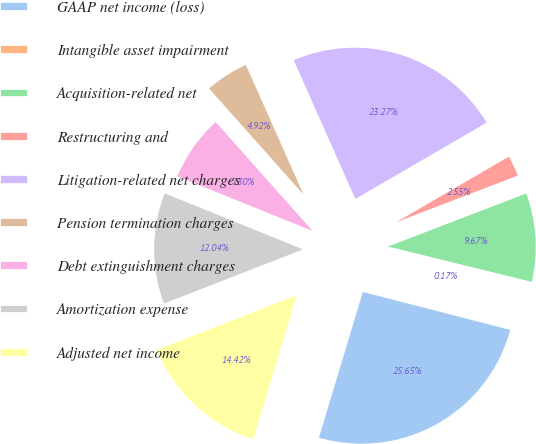Convert chart. <chart><loc_0><loc_0><loc_500><loc_500><pie_chart><fcel>GAAP net income (loss)<fcel>Intangible asset impairment<fcel>Acquisition-related net<fcel>Restructuring and<fcel>Litigation-related net charges<fcel>Pension termination charges<fcel>Debt extinguishment charges<fcel>Amortization expense<fcel>Adjusted net income<nl><fcel>25.65%<fcel>0.17%<fcel>9.67%<fcel>2.55%<fcel>23.27%<fcel>4.92%<fcel>7.3%<fcel>12.04%<fcel>14.42%<nl></chart> 